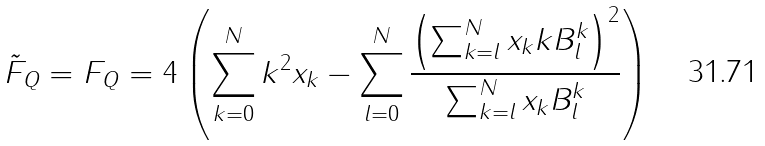<formula> <loc_0><loc_0><loc_500><loc_500>\tilde { F } _ { Q } = F _ { Q } = 4 \left ( \sum _ { k = 0 } ^ { N } k ^ { 2 } x _ { k } - \sum _ { l = 0 } ^ { N } \frac { \left ( \sum _ { k = l } ^ { N } x _ { k } k B ^ { k } _ { l } \right ) ^ { 2 } } { \sum _ { k = l } ^ { N } x _ { k } B ^ { k } _ { l } } \right )</formula> 